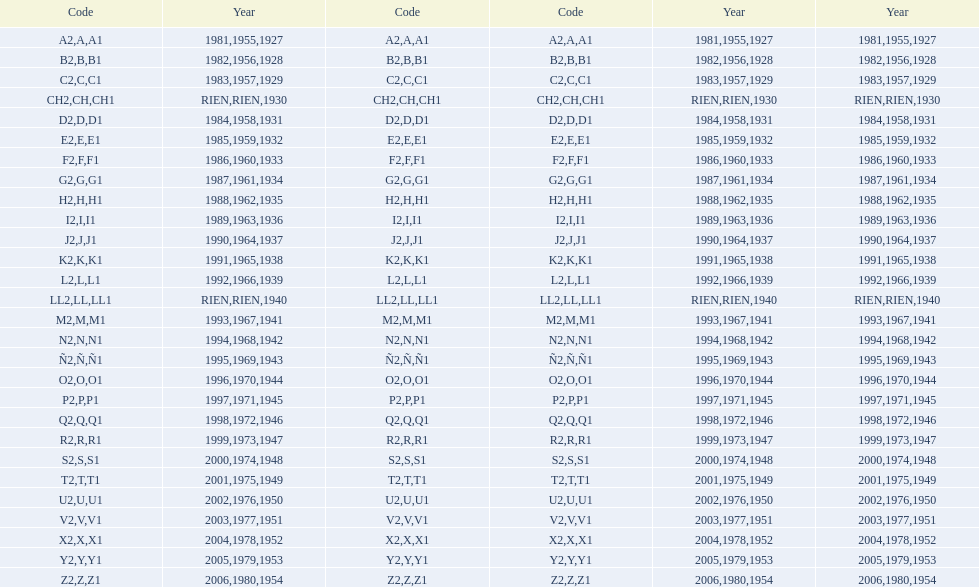What was the lowest year stamped? 1927. 